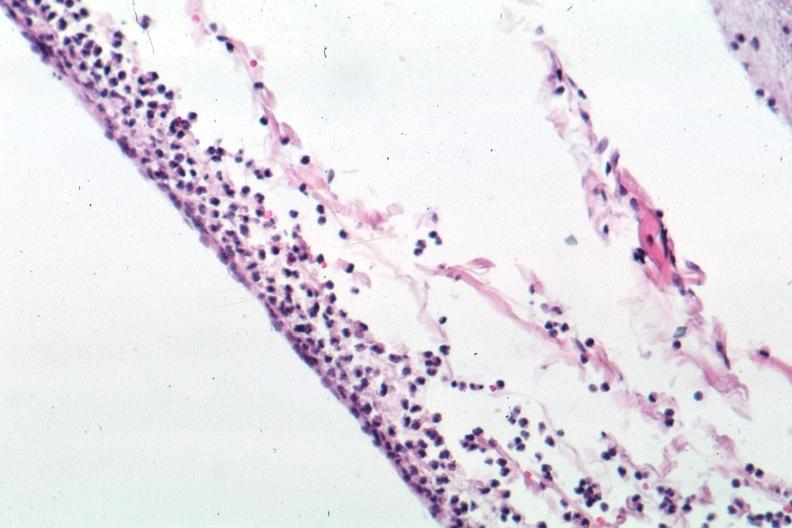what does this image show?
Answer the question using a single word or phrase. Well shown meningitis purulent 